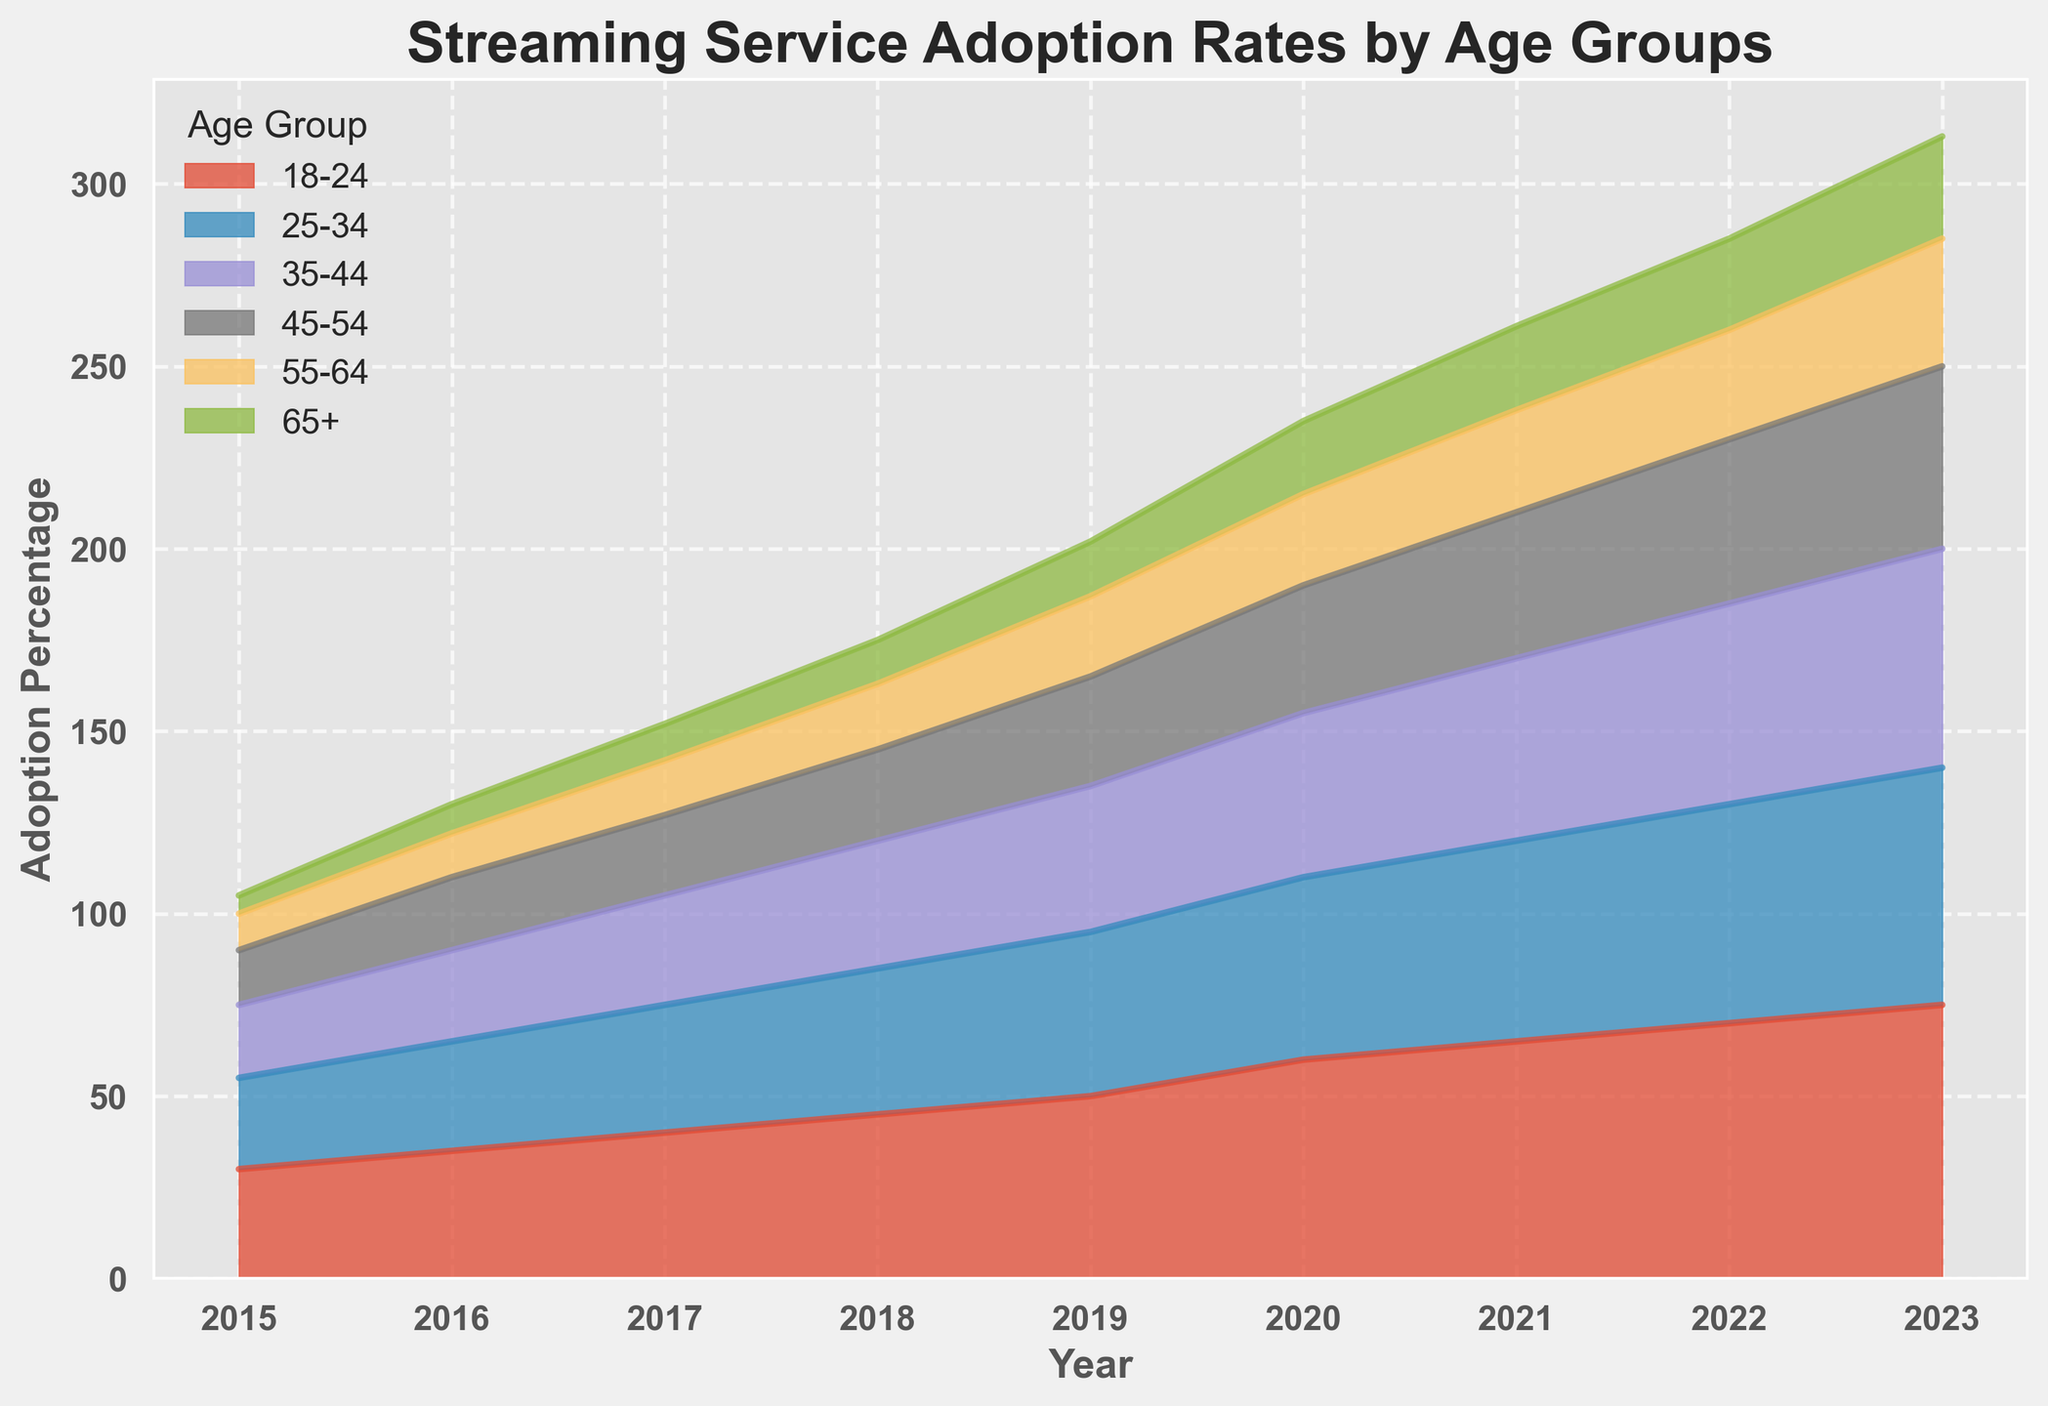Which age group showed the highest streaming service adoption rate in 2023? Look at the color-coded regions in the area chart for the year 2023 and find the tallest one. The age group 18-24 has the highest percentage.
Answer: 18-24 Between 2015 and 2023, how much did the adoption rate for the 25-34 age group increase? Check the height of the area for the age group 25-34 in both 2015 and 2023 and subtract the early value from the later one. It increased from 25% to 65%, so the difference is 65% - 25%.
Answer: 40% Compare the adoption rates for the 35-44 and 55-64 age groups in 2020. Which group had a higher adoption percentage and by how much? Find the heights of the areas for the 35-44 and 55-64 age groups in 2020 and subtract the smaller from the larger. The 35-44 group had a higher percentage of 45% compared to the 55-64 group’s 25%, so the difference is 45% - 25%.
Answer: 35-44 by 20% What was the average adoption rate for the 45-54 age group from 2015 to 2023? Sum the data points for the 45-54 age group from 2015 to 2023 and divide by the number of years. The percentages are 15, 20, 22, 25, 30, 35, 40, 45, 50; sum these to get 282, then divide by 9 years.
Answer: 31.33% In which year did the 65+ age group surpass a 20% adoption rate for the first time? Observe the heights of the area corresponding to the 65+ age group and identify the first year where this segment exceeds 20%. This occurs in 2020.
Answer: 2020 By how many percentage points did the 18-24 age group’s adoption rate increase between 2016 and 2021? Look at the data points for the 18-24 age group in 2016 and 2021, and subtract the earlier percentage from the later percentage. The increase is from 35% to 65%, so the difference is 65% - 35%.
Answer: 30% How did the percentage change for the 55-64 age group from 2018 to 2019 compare to its change from 2019 to 2020? Find the differences for each period: from 2018 to 2019 it changed from 18% to 22%, an increase of 4%. From 2019 to 2020 it changed from 22% to 25%, an increase of 3%. Compare these two differences.
Answer: 4% and 3% Which two age groups had the same adoption rate in 2018, and what was that rate? Check the heights of the areas for each age group in 2018 to find two groups with identical heights. Both the 25-34 and 35-44 age groups had a rate of 35%.
Answer: 25-34 and 35-44, 35% What is the overall trend for streaming service adoption rates from 2015 to 2023 across all age groups? Observe the general upward trend in the heights of the areas for each age group over the years. All groups show increasing adoption rates over time.
Answer: Increasing How much more did the 18-24 age group increase its adoption rate from 2017 to 2023 compared to the 65+ age group in the same period? Calculate the difference in adoption rates for each group between the two years, then subtract one difference from the other. For 18-24, the increase is from 40% to 75% (35% increase); for 65+, it's from 10% to 28% (18% increase). The difference between the two increases is 35% - 18%.
Answer: 17% 